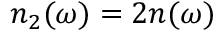Convert formula to latex. <formula><loc_0><loc_0><loc_500><loc_500>n _ { 2 } ( \omega ) = 2 n ( \omega )</formula> 